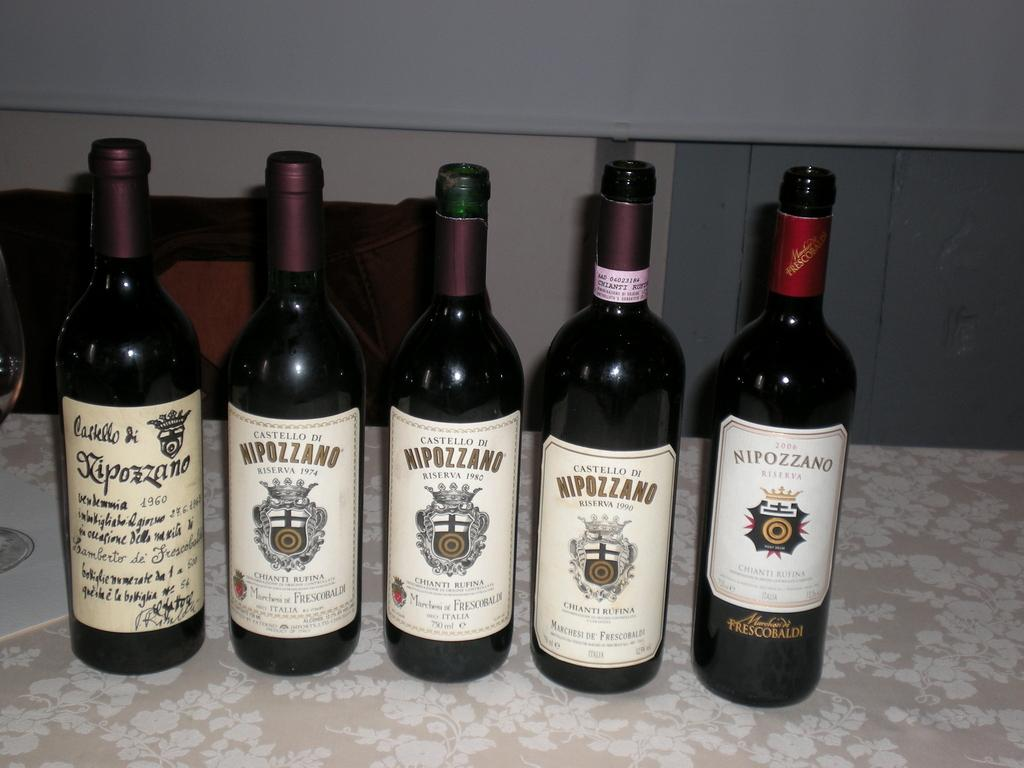Provide a one-sentence caption for the provided image. 5 bottles of wine bottled by the company Nipozzano. 